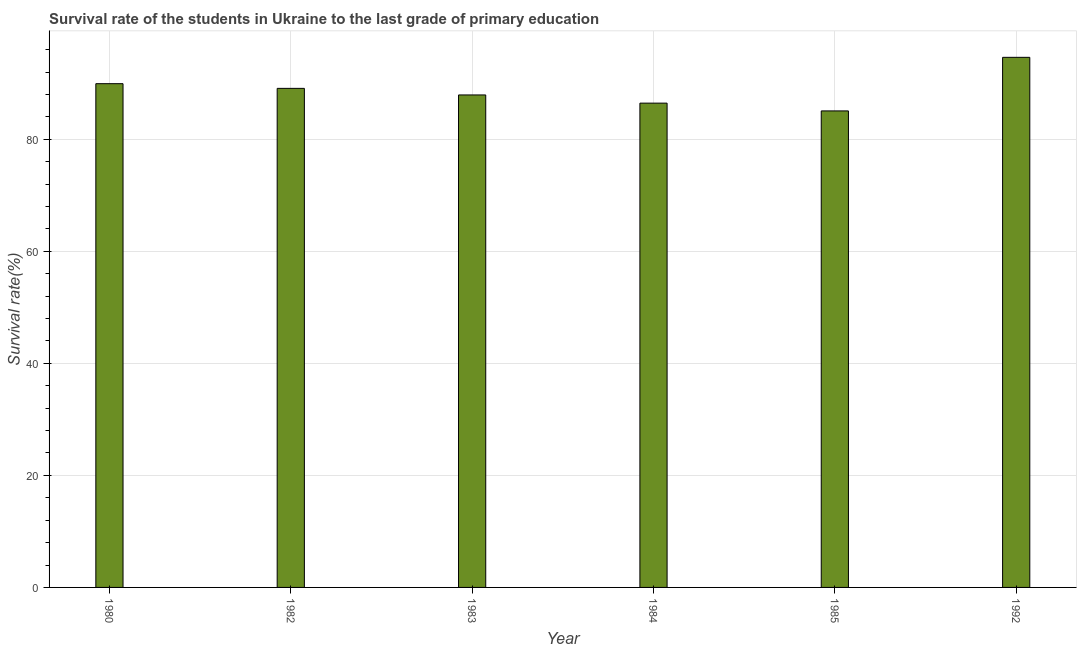What is the title of the graph?
Offer a terse response. Survival rate of the students in Ukraine to the last grade of primary education. What is the label or title of the Y-axis?
Provide a short and direct response. Survival rate(%). What is the survival rate in primary education in 1983?
Make the answer very short. 87.93. Across all years, what is the maximum survival rate in primary education?
Offer a terse response. 94.64. Across all years, what is the minimum survival rate in primary education?
Your response must be concise. 85.07. In which year was the survival rate in primary education maximum?
Ensure brevity in your answer.  1992. What is the sum of the survival rate in primary education?
Offer a very short reply. 533.14. What is the difference between the survival rate in primary education in 1983 and 1985?
Make the answer very short. 2.85. What is the average survival rate in primary education per year?
Ensure brevity in your answer.  88.86. What is the median survival rate in primary education?
Ensure brevity in your answer.  88.51. Do a majority of the years between 1992 and 1985 (inclusive) have survival rate in primary education greater than 44 %?
Offer a terse response. No. What is the ratio of the survival rate in primary education in 1982 to that in 1985?
Offer a very short reply. 1.05. Is the difference between the survival rate in primary education in 1982 and 1985 greater than the difference between any two years?
Keep it short and to the point. No. What is the difference between the highest and the second highest survival rate in primary education?
Your answer should be compact. 4.7. What is the difference between the highest and the lowest survival rate in primary education?
Your answer should be very brief. 9.57. How many years are there in the graph?
Offer a very short reply. 6. What is the difference between two consecutive major ticks on the Y-axis?
Your response must be concise. 20. What is the Survival rate(%) of 1980?
Your answer should be compact. 89.94. What is the Survival rate(%) in 1982?
Ensure brevity in your answer.  89.1. What is the Survival rate(%) in 1983?
Your response must be concise. 87.93. What is the Survival rate(%) in 1984?
Provide a short and direct response. 86.46. What is the Survival rate(%) in 1985?
Offer a very short reply. 85.07. What is the Survival rate(%) of 1992?
Keep it short and to the point. 94.64. What is the difference between the Survival rate(%) in 1980 and 1982?
Keep it short and to the point. 0.84. What is the difference between the Survival rate(%) in 1980 and 1983?
Make the answer very short. 2.01. What is the difference between the Survival rate(%) in 1980 and 1984?
Offer a terse response. 3.48. What is the difference between the Survival rate(%) in 1980 and 1985?
Ensure brevity in your answer.  4.86. What is the difference between the Survival rate(%) in 1980 and 1992?
Keep it short and to the point. -4.7. What is the difference between the Survival rate(%) in 1982 and 1983?
Ensure brevity in your answer.  1.17. What is the difference between the Survival rate(%) in 1982 and 1984?
Keep it short and to the point. 2.64. What is the difference between the Survival rate(%) in 1982 and 1985?
Provide a short and direct response. 4.03. What is the difference between the Survival rate(%) in 1982 and 1992?
Your answer should be very brief. -5.54. What is the difference between the Survival rate(%) in 1983 and 1984?
Provide a short and direct response. 1.46. What is the difference between the Survival rate(%) in 1983 and 1985?
Make the answer very short. 2.85. What is the difference between the Survival rate(%) in 1983 and 1992?
Your answer should be compact. -6.72. What is the difference between the Survival rate(%) in 1984 and 1985?
Your response must be concise. 1.39. What is the difference between the Survival rate(%) in 1984 and 1992?
Offer a very short reply. -8.18. What is the difference between the Survival rate(%) in 1985 and 1992?
Make the answer very short. -9.57. What is the ratio of the Survival rate(%) in 1980 to that in 1985?
Offer a terse response. 1.06. What is the ratio of the Survival rate(%) in 1980 to that in 1992?
Your answer should be compact. 0.95. What is the ratio of the Survival rate(%) in 1982 to that in 1984?
Offer a very short reply. 1.03. What is the ratio of the Survival rate(%) in 1982 to that in 1985?
Ensure brevity in your answer.  1.05. What is the ratio of the Survival rate(%) in 1982 to that in 1992?
Your answer should be very brief. 0.94. What is the ratio of the Survival rate(%) in 1983 to that in 1985?
Offer a terse response. 1.03. What is the ratio of the Survival rate(%) in 1983 to that in 1992?
Offer a very short reply. 0.93. What is the ratio of the Survival rate(%) in 1984 to that in 1985?
Offer a very short reply. 1.02. What is the ratio of the Survival rate(%) in 1984 to that in 1992?
Make the answer very short. 0.91. What is the ratio of the Survival rate(%) in 1985 to that in 1992?
Ensure brevity in your answer.  0.9. 